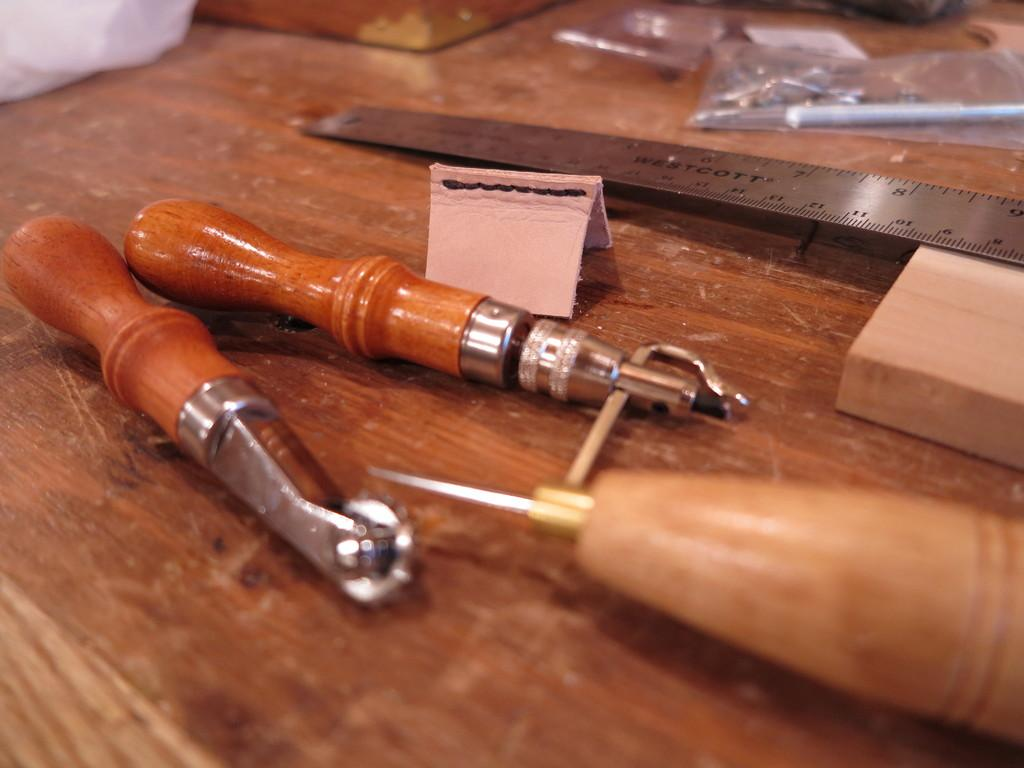What is the color of the surface in the image? The surface in the image is brown. What can be found on the brown surface? There are tools and an iron scale on the brown surface. Can you describe the background of the image? The background of the image is blurry. How does the disgust factor contribute to the educational value of the image? The image does not contain any elements related to disgust or education, so these factors cannot be assessed in the context of the image. 